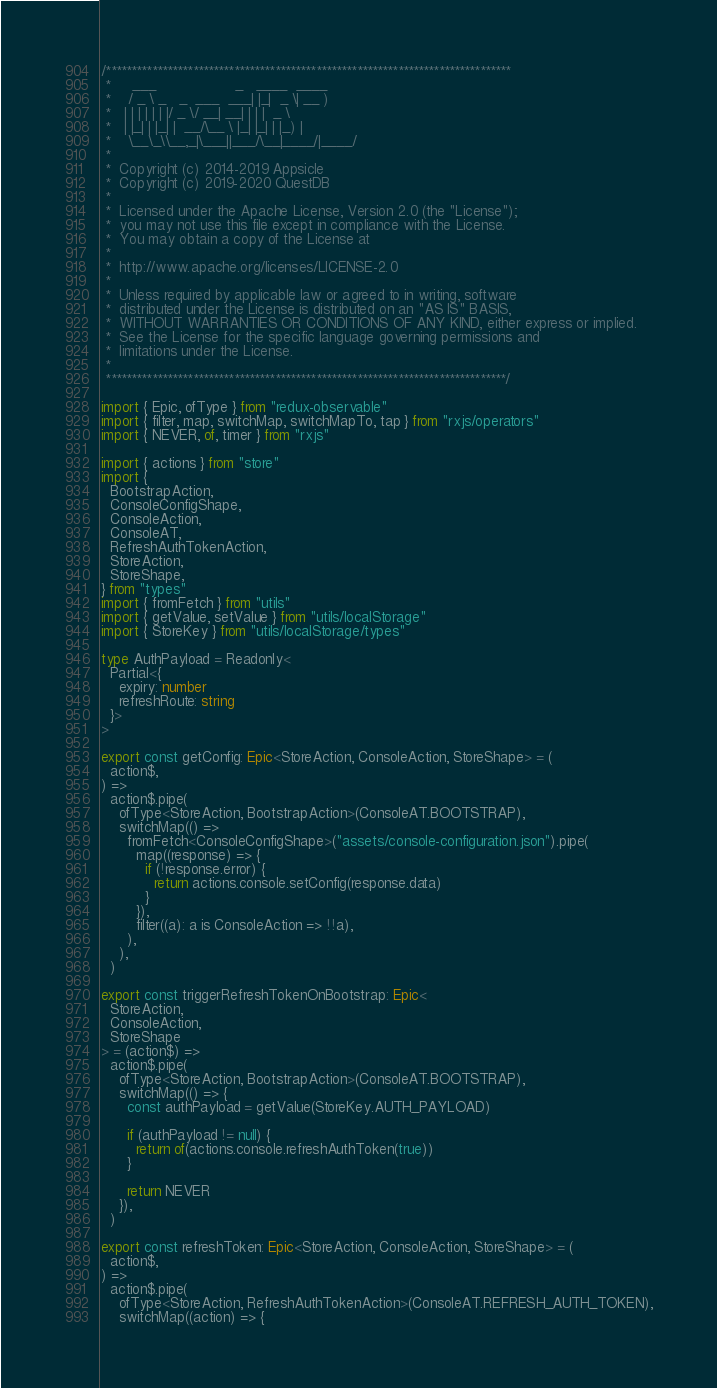<code> <loc_0><loc_0><loc_500><loc_500><_TypeScript_>/*******************************************************************************
 *     ___                  _   ____  ____
 *    / _ \ _   _  ___  ___| |_|  _ \| __ )
 *   | | | | | | |/ _ \/ __| __| | | |  _ \
 *   | |_| | |_| |  __/\__ \ |_| |_| | |_) |
 *    \__\_\\__,_|\___||___/\__|____/|____/
 *
 *  Copyright (c) 2014-2019 Appsicle
 *  Copyright (c) 2019-2020 QuestDB
 *
 *  Licensed under the Apache License, Version 2.0 (the "License");
 *  you may not use this file except in compliance with the License.
 *  You may obtain a copy of the License at
 *
 *  http://www.apache.org/licenses/LICENSE-2.0
 *
 *  Unless required by applicable law or agreed to in writing, software
 *  distributed under the License is distributed on an "AS IS" BASIS,
 *  WITHOUT WARRANTIES OR CONDITIONS OF ANY KIND, either express or implied.
 *  See the License for the specific language governing permissions and
 *  limitations under the License.
 *
 ******************************************************************************/

import { Epic, ofType } from "redux-observable"
import { filter, map, switchMap, switchMapTo, tap } from "rxjs/operators"
import { NEVER, of, timer } from "rxjs"

import { actions } from "store"
import {
  BootstrapAction,
  ConsoleConfigShape,
  ConsoleAction,
  ConsoleAT,
  RefreshAuthTokenAction,
  StoreAction,
  StoreShape,
} from "types"
import { fromFetch } from "utils"
import { getValue, setValue } from "utils/localStorage"
import { StoreKey } from "utils/localStorage/types"

type AuthPayload = Readonly<
  Partial<{
    expiry: number
    refreshRoute: string
  }>
>

export const getConfig: Epic<StoreAction, ConsoleAction, StoreShape> = (
  action$,
) =>
  action$.pipe(
    ofType<StoreAction, BootstrapAction>(ConsoleAT.BOOTSTRAP),
    switchMap(() =>
      fromFetch<ConsoleConfigShape>("assets/console-configuration.json").pipe(
        map((response) => {
          if (!response.error) {
            return actions.console.setConfig(response.data)
          }
        }),
        filter((a): a is ConsoleAction => !!a),
      ),
    ),
  )

export const triggerRefreshTokenOnBootstrap: Epic<
  StoreAction,
  ConsoleAction,
  StoreShape
> = (action$) =>
  action$.pipe(
    ofType<StoreAction, BootstrapAction>(ConsoleAT.BOOTSTRAP),
    switchMap(() => {
      const authPayload = getValue(StoreKey.AUTH_PAYLOAD)

      if (authPayload != null) {
        return of(actions.console.refreshAuthToken(true))
      }

      return NEVER
    }),
  )

export const refreshToken: Epic<StoreAction, ConsoleAction, StoreShape> = (
  action$,
) =>
  action$.pipe(
    ofType<StoreAction, RefreshAuthTokenAction>(ConsoleAT.REFRESH_AUTH_TOKEN),
    switchMap((action) => {</code> 